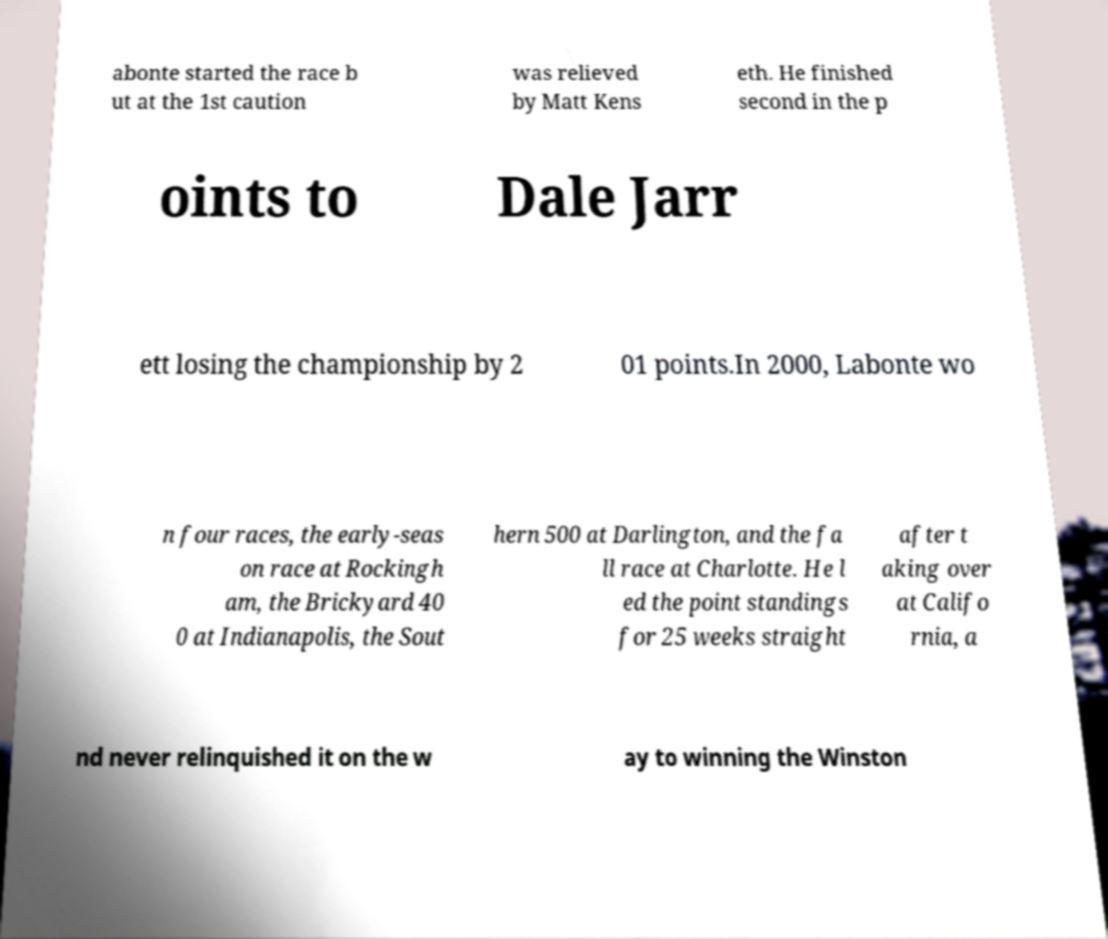Please read and relay the text visible in this image. What does it say? abonte started the race b ut at the 1st caution was relieved by Matt Kens eth. He finished second in the p oints to Dale Jarr ett losing the championship by 2 01 points.In 2000, Labonte wo n four races, the early-seas on race at Rockingh am, the Brickyard 40 0 at Indianapolis, the Sout hern 500 at Darlington, and the fa ll race at Charlotte. He l ed the point standings for 25 weeks straight after t aking over at Califo rnia, a nd never relinquished it on the w ay to winning the Winston 